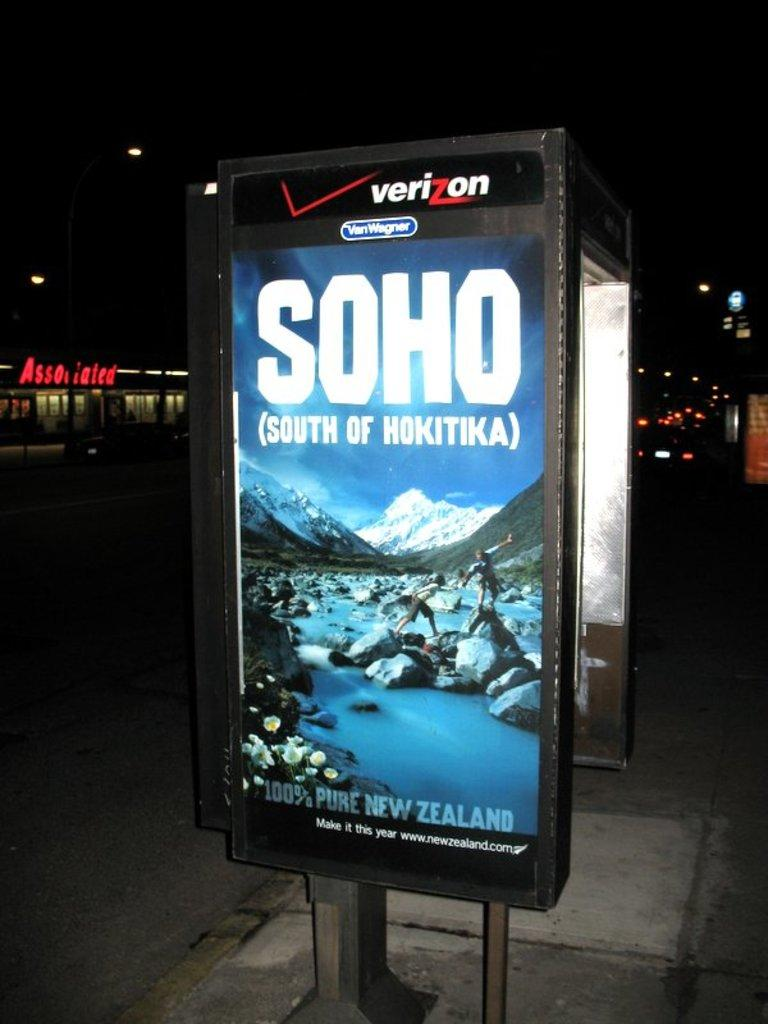<image>
Relay a brief, clear account of the picture shown. a poster on the sidewalk that says 'soho south of hokitika' on it 